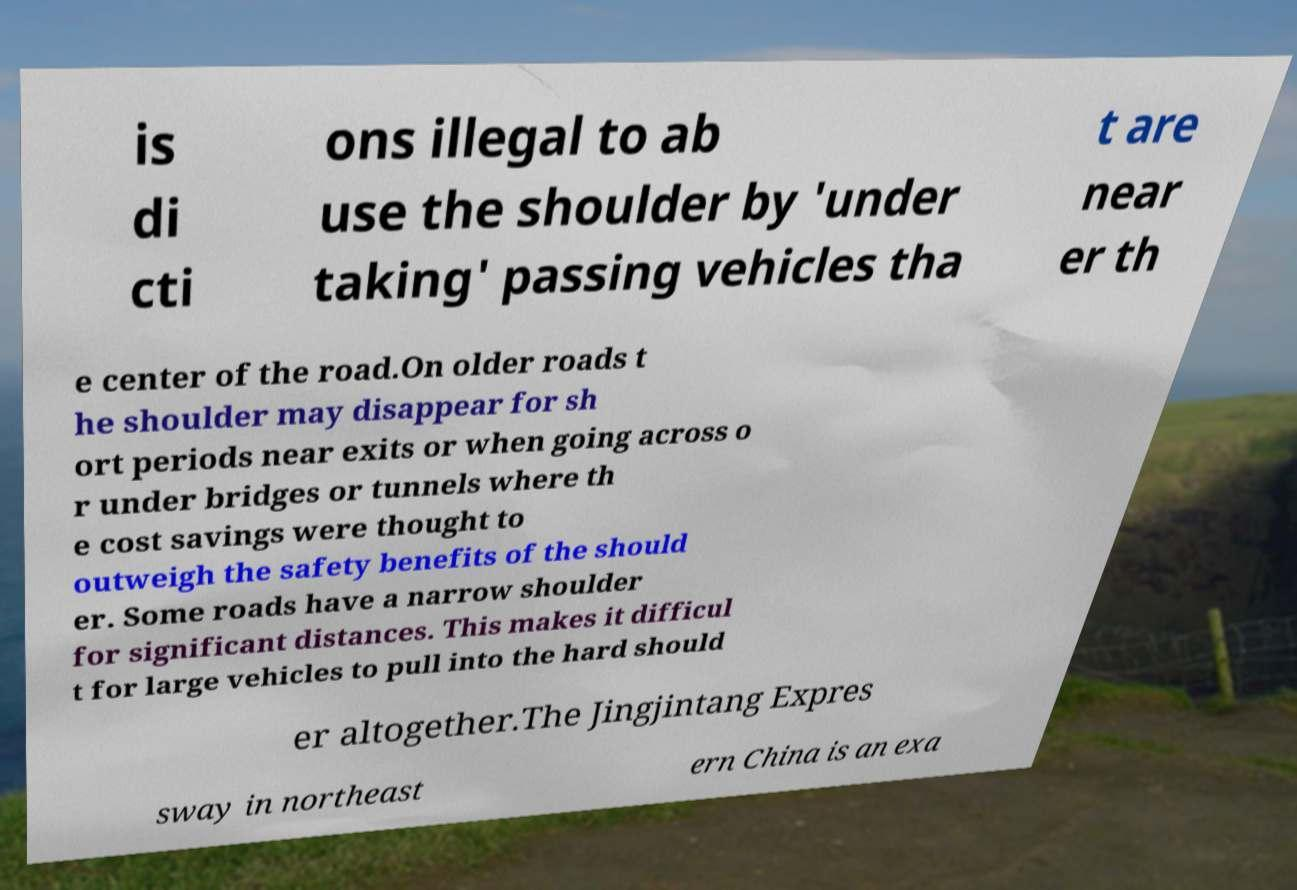Could you extract and type out the text from this image? is di cti ons illegal to ab use the shoulder by 'under taking' passing vehicles tha t are near er th e center of the road.On older roads t he shoulder may disappear for sh ort periods near exits or when going across o r under bridges or tunnels where th e cost savings were thought to outweigh the safety benefits of the should er. Some roads have a narrow shoulder for significant distances. This makes it difficul t for large vehicles to pull into the hard should er altogether.The Jingjintang Expres sway in northeast ern China is an exa 